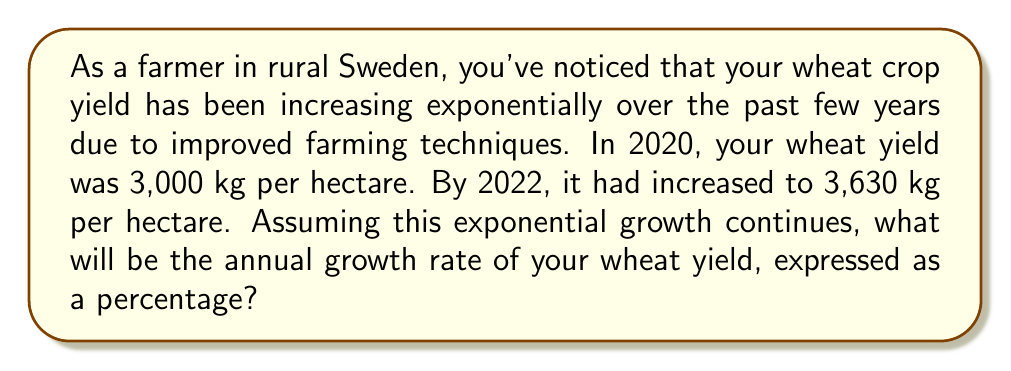Give your solution to this math problem. Let's approach this step-by-step:

1) We can use the exponential growth formula:
   $$ A = P(1 + r)^t $$
   Where:
   $A$ is the final amount
   $P$ is the initial amount
   $r$ is the annual growth rate (in decimal form)
   $t$ is the time in years

2) We know:
   $P = 3000$ kg/hectare (in 2020)
   $A = 3630$ kg/hectare (in 2022)
   $t = 2$ years

3) Let's plug these into our formula:
   $$ 3630 = 3000(1 + r)^2 $$

4) Divide both sides by 3000:
   $$ 1.21 = (1 + r)^2 $$

5) Take the square root of both sides:
   $$ \sqrt{1.21} = 1 + r $$

6) Simplify:
   $$ 1.1 = 1 + r $$

7) Subtract 1 from both sides:
   $$ r = 0.1 $$

8) To convert to a percentage, multiply by 100:
   $$ 0.1 * 100 = 10\% $$

Therefore, the annual growth rate is 10%.
Answer: The annual growth rate of the wheat yield is 10%. 